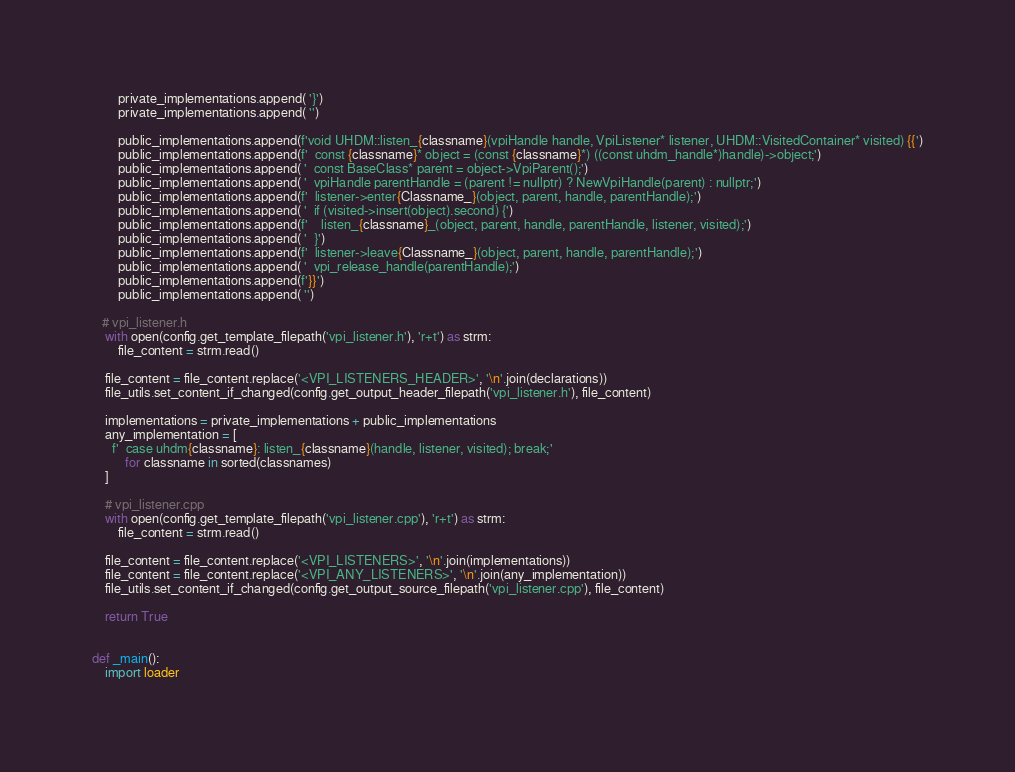<code> <loc_0><loc_0><loc_500><loc_500><_Python_>        private_implementations.append( '}')
        private_implementations.append( '')

        public_implementations.append(f'void UHDM::listen_{classname}(vpiHandle handle, VpiListener* listener, UHDM::VisitedContainer* visited) {{')
        public_implementations.append(f'  const {classname}* object = (const {classname}*) ((const uhdm_handle*)handle)->object;')
        public_implementations.append( '  const BaseClass* parent = object->VpiParent();')
        public_implementations.append( '  vpiHandle parentHandle = (parent != nullptr) ? NewVpiHandle(parent) : nullptr;')
        public_implementations.append(f'  listener->enter{Classname_}(object, parent, handle, parentHandle);')
        public_implementations.append( '  if (visited->insert(object).second) {')
        public_implementations.append(f'    listen_{classname}_(object, parent, handle, parentHandle, listener, visited);')
        public_implementations.append( '  }')
        public_implementations.append(f'  listener->leave{Classname_}(object, parent, handle, parentHandle);')
        public_implementations.append( '  vpi_release_handle(parentHandle);')
        public_implementations.append(f'}}')
        public_implementations.append( '')

   # vpi_listener.h
    with open(config.get_template_filepath('vpi_listener.h'), 'r+t') as strm:
        file_content = strm.read()

    file_content = file_content.replace('<VPI_LISTENERS_HEADER>', '\n'.join(declarations))
    file_utils.set_content_if_changed(config.get_output_header_filepath('vpi_listener.h'), file_content)

    implementations = private_implementations + public_implementations
    any_implementation = [
      f'  case uhdm{classname}: listen_{classname}(handle, listener, visited); break;'
          for classname in sorted(classnames)
    ]

    # vpi_listener.cpp
    with open(config.get_template_filepath('vpi_listener.cpp'), 'r+t') as strm:
        file_content = strm.read()

    file_content = file_content.replace('<VPI_LISTENERS>', '\n'.join(implementations))
    file_content = file_content.replace('<VPI_ANY_LISTENERS>', '\n'.join(any_implementation))
    file_utils.set_content_if_changed(config.get_output_source_filepath('vpi_listener.cpp'), file_content)

    return True


def _main():
    import loader
</code> 